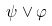<formula> <loc_0><loc_0><loc_500><loc_500>\psi \vee \varphi</formula> 